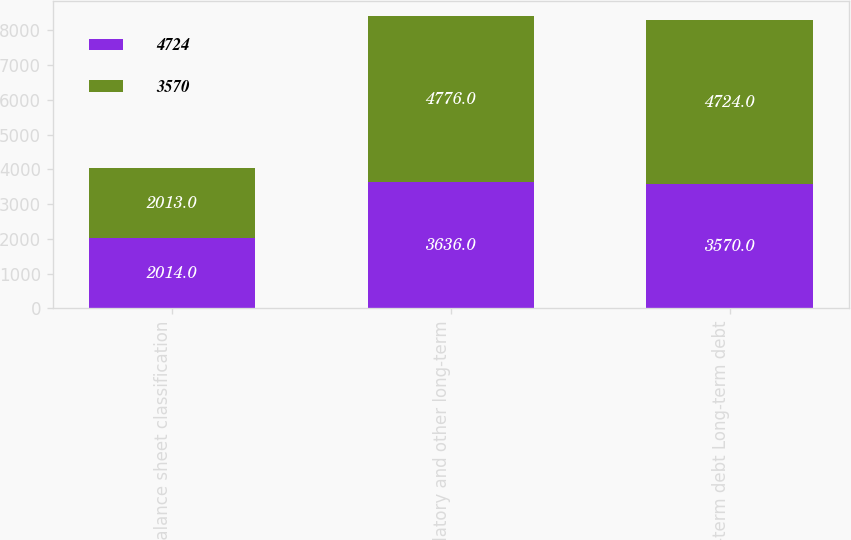Convert chart. <chart><loc_0><loc_0><loc_500><loc_500><stacked_bar_chart><ecel><fcel>Balance sheet classification<fcel>Regulatory and other long-term<fcel>Long-term debt Long-term debt<nl><fcel>4724<fcel>2014<fcel>3636<fcel>3570<nl><fcel>3570<fcel>2013<fcel>4776<fcel>4724<nl></chart> 